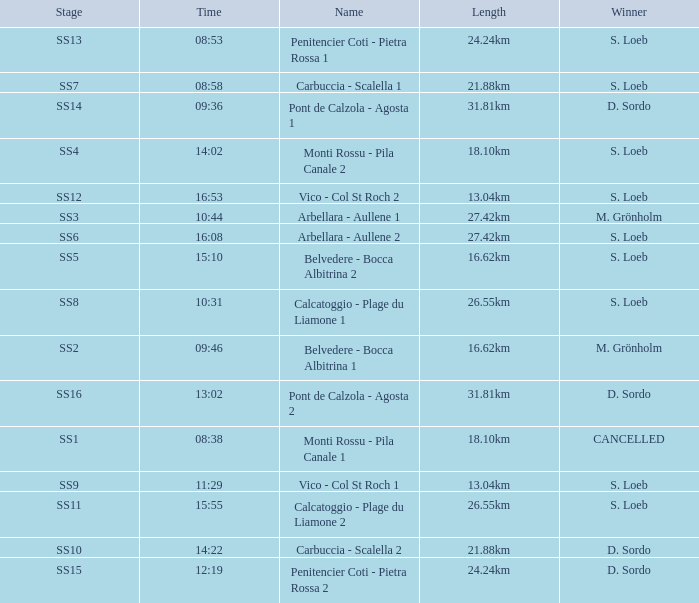What is the Name of the stage with S. Loeb as the Winner with a Length of 13.04km and a Stage of SS12? Vico - Col St Roch 2. 